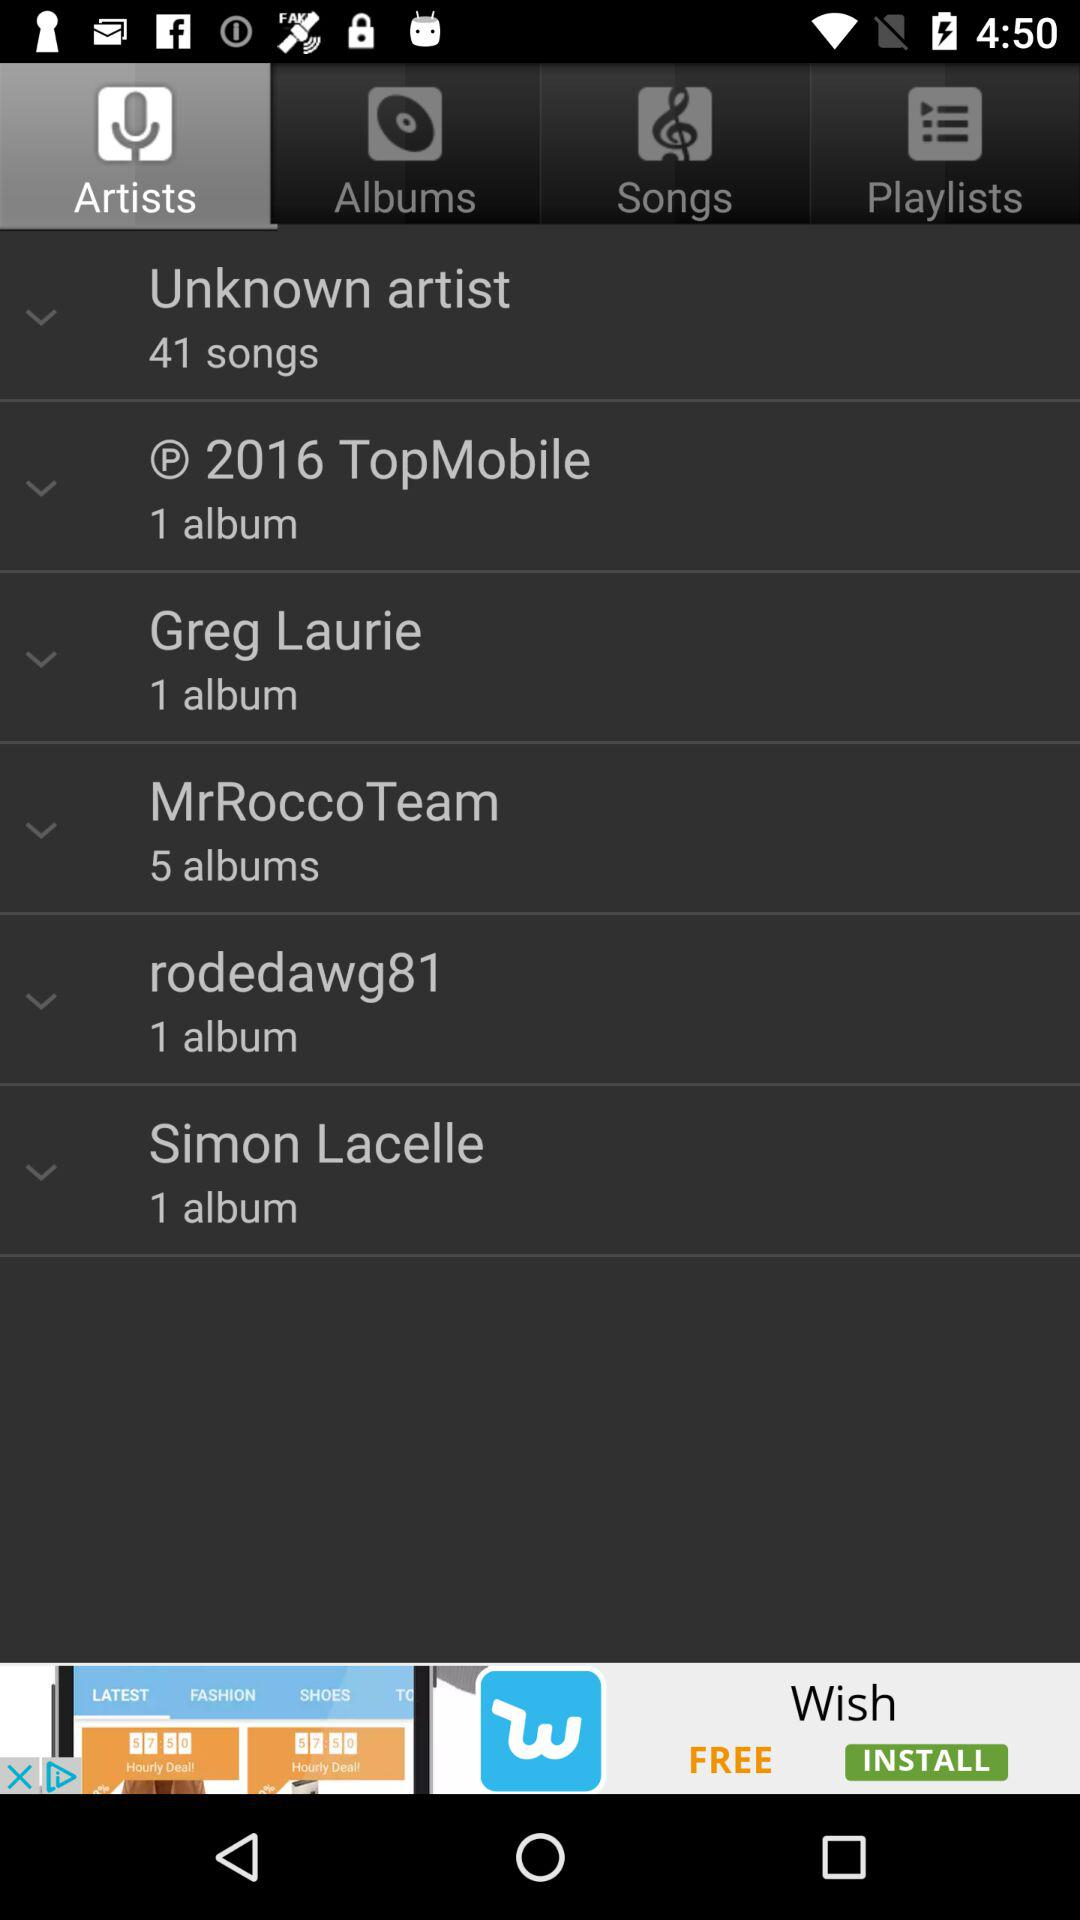Which tab has been selected? The tab "Artists" has been selected. 